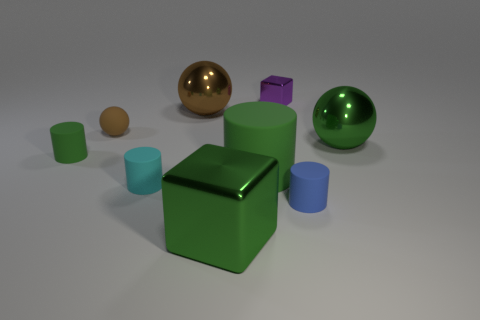The other rubber cylinder that is the same color as the large cylinder is what size?
Provide a short and direct response. Small. How many green objects are to the left of the cyan rubber cylinder and in front of the blue object?
Your answer should be very brief. 0. There is a big green object that is the same shape as the tiny brown thing; what is its material?
Ensure brevity in your answer.  Metal. There is a green rubber thing that is behind the green cylinder on the right side of the brown metal ball; how big is it?
Make the answer very short. Small. Is there a big brown cylinder?
Ensure brevity in your answer.  No. There is a thing that is both behind the small ball and in front of the tiny purple metal thing; what is its material?
Provide a succinct answer. Metal. Are there more objects that are on the right side of the big green ball than tiny blue rubber things to the left of the small cyan cylinder?
Ensure brevity in your answer.  No. Is there a purple shiny thing that has the same size as the purple metallic cube?
Your answer should be compact. No. What size is the cube that is in front of the metal object to the right of the small object that is behind the tiny brown matte thing?
Your answer should be very brief. Large. The big cylinder is what color?
Your answer should be compact. Green. 